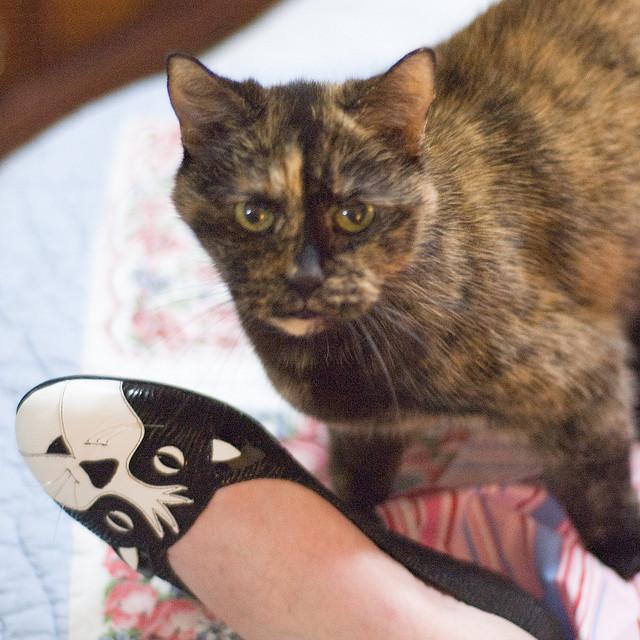What is one of the largest breeds of this animal? cat 